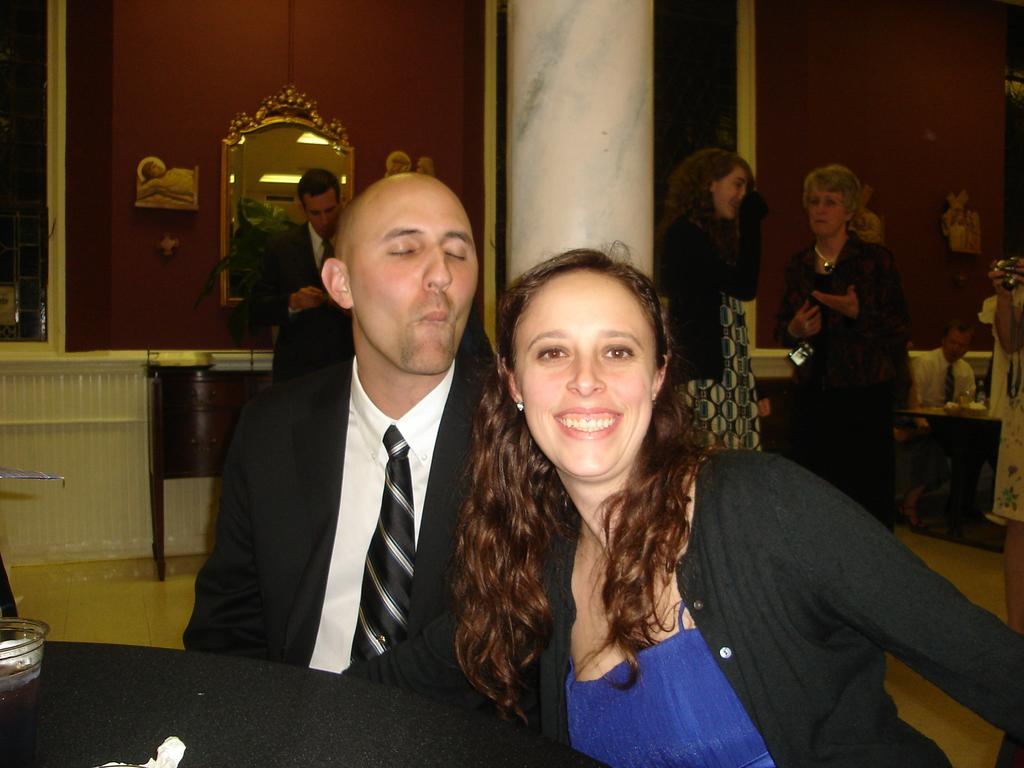Describe this image in one or two sentences. In this image we can see a man and woman is sitting. In front of them black color table is there, on table one glass is there. The man is wearing suit and the woman is wearing blue and black color dress. Behind people are standing and sitting. One white color pillar is there,. The walls of the room is in red color and one mirror is attached to the wall. 